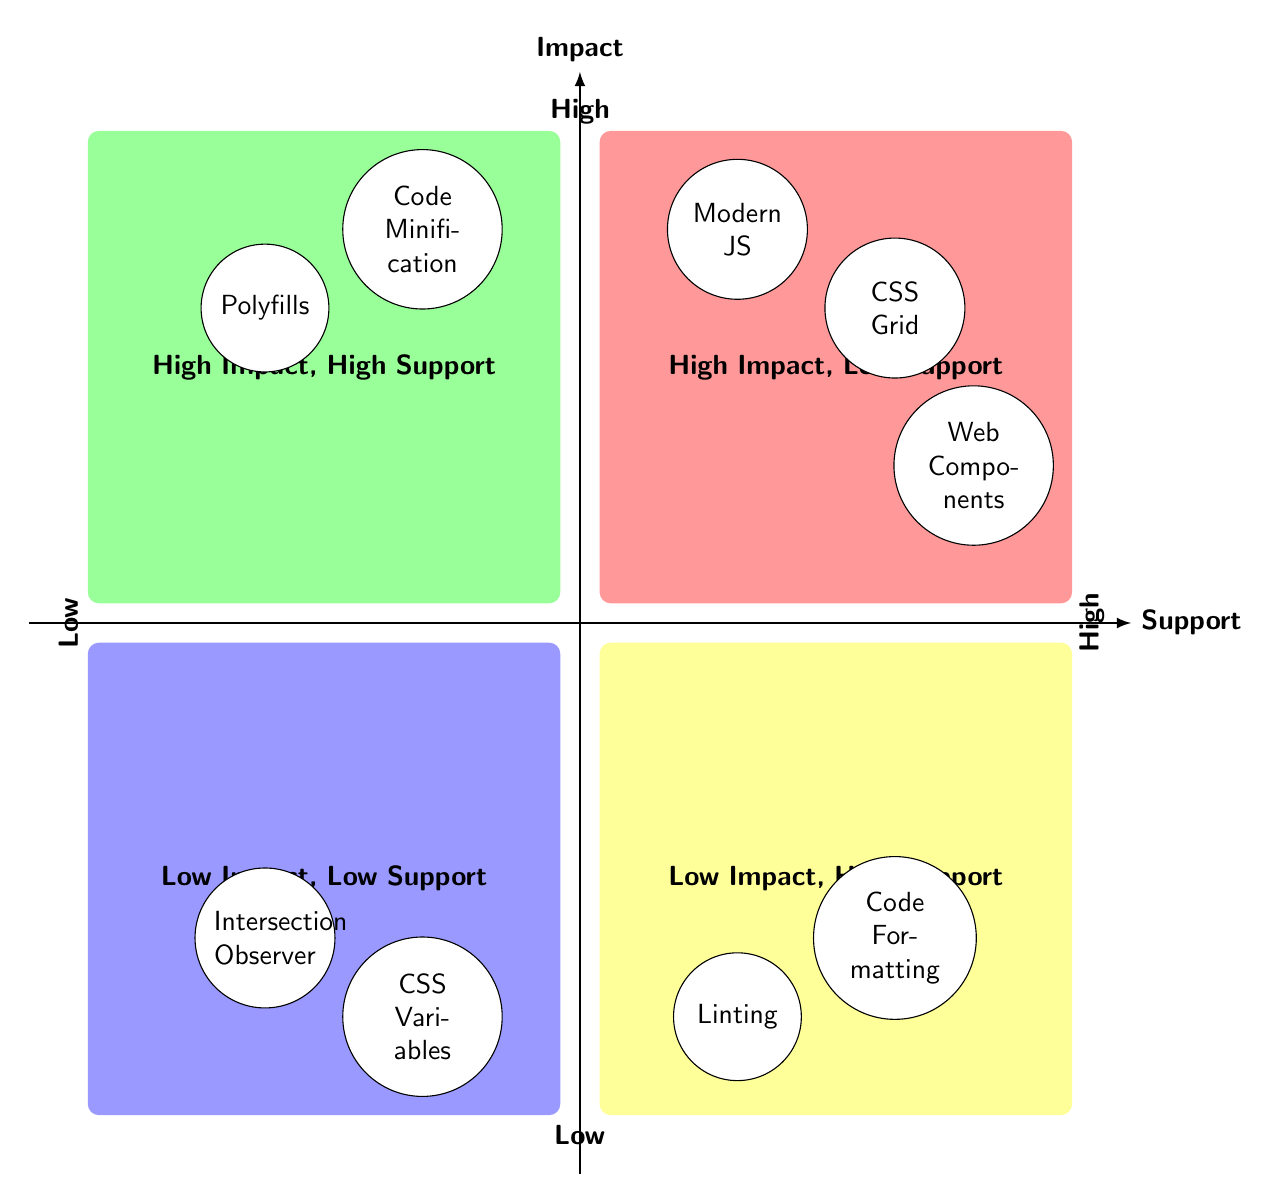What's in the "High Impact, Low Support" quadrant? The "High Impact, Low Support" quadrant contains three elements: Modern JavaScript Features, CSS Grid Layout, and Web Components.
Answer: Modern JavaScript Features, CSS Grid Layout, Web Components How many elements are in the "Low Impact, High Support" quadrant? The "Low Impact, High Support" quadrant has two elements: Linting and Code Formatting.
Answer: 2 Which quadrant contains "Code Minification"? "Code Minification" is found in the "High Impact, High Support" quadrant, as it is a practice that generally supports all browsers and has a significant performance impact.
Answer: High Impact, High Support What are the two elements in the "Low Impact, Low Support" quadrant? The two elements in this quadrant are CSS Variables and Intersection Observer, both of which have limited support in older browsers.
Answer: CSS Variables, Intersection Observer Which element has the highest support but low impact? The element with the highest support but low impact is Linting, as it ensures code quality without any significant effect on browser support.
Answer: Linting How does "Polyfills" contribute to browser support? "Polyfills" allow missing features in older browsers by adding necessary code to support newer functionalities, hence enhancing overall browser compatibility.
Answer: Adds support What distinguishes "High Impact, High Support" from other quadrants? The "High Impact, High Support" quadrant holds elements that significantly enhance performance or capabilities while being broadly supported across various browsers, unlike the high impact but low support elements.
Answer: Performance and broad support Which quadrant would you refer for features needing modern JavaScript and not supporting older browsers? You would refer to the "High Impact, Low Support" quadrant for features like modern JavaScript that have significant impact but lack support in older browsers like Internet Explorer.
Answer: High Impact, Low Support 